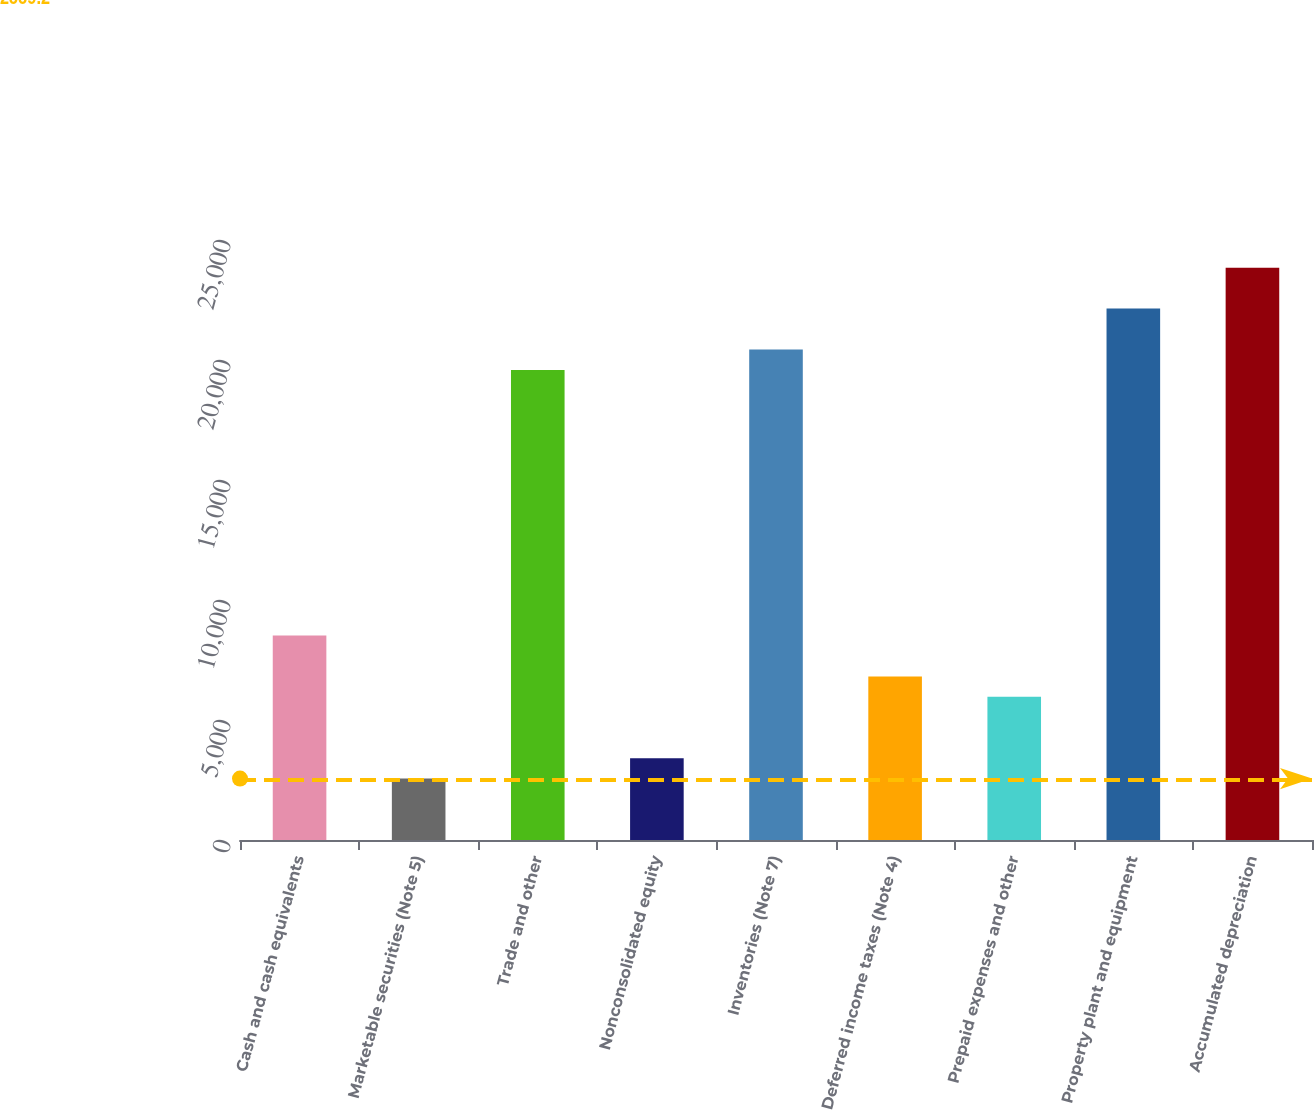Convert chart to OTSL. <chart><loc_0><loc_0><loc_500><loc_500><bar_chart><fcel>Cash and cash equivalents<fcel>Marketable securities (Note 5)<fcel>Trade and other<fcel>Nonconsolidated equity<fcel>Inventories (Note 7)<fcel>Deferred income taxes (Note 4)<fcel>Prepaid expenses and other<fcel>Property plant and equipment<fcel>Accumulated depreciation<nl><fcel>8519<fcel>2559.2<fcel>19587.2<fcel>3410.6<fcel>20438.6<fcel>6816.2<fcel>5964.8<fcel>22141.4<fcel>23844.2<nl></chart> 